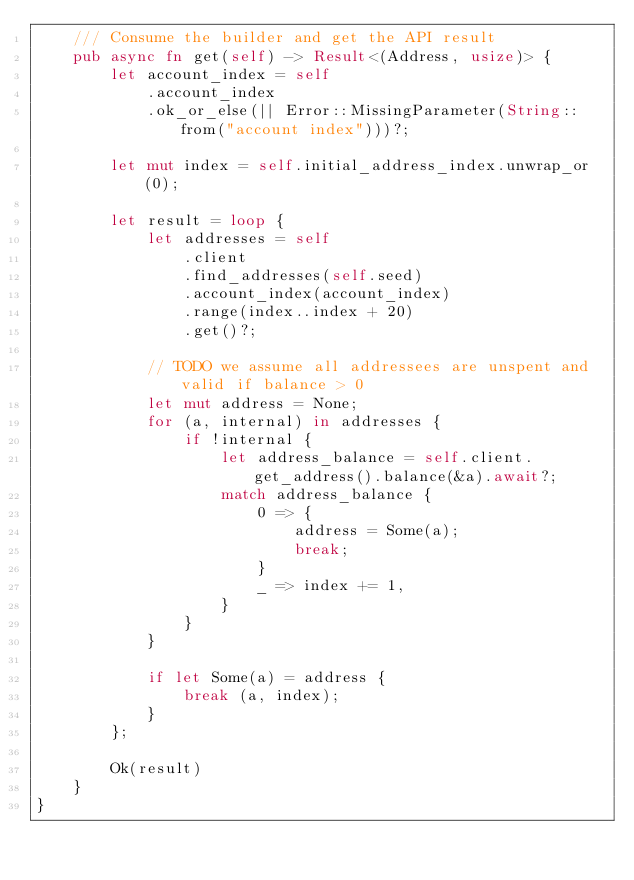Convert code to text. <code><loc_0><loc_0><loc_500><loc_500><_Rust_>    /// Consume the builder and get the API result
    pub async fn get(self) -> Result<(Address, usize)> {
        let account_index = self
            .account_index
            .ok_or_else(|| Error::MissingParameter(String::from("account index")))?;

        let mut index = self.initial_address_index.unwrap_or(0);

        let result = loop {
            let addresses = self
                .client
                .find_addresses(self.seed)
                .account_index(account_index)
                .range(index..index + 20)
                .get()?;

            // TODO we assume all addressees are unspent and valid if balance > 0
            let mut address = None;
            for (a, internal) in addresses {
                if !internal {
                    let address_balance = self.client.get_address().balance(&a).await?;
                    match address_balance {
                        0 => {
                            address = Some(a);
                            break;
                        }
                        _ => index += 1,
                    }
                }
            }

            if let Some(a) = address {
                break (a, index);
            }
        };

        Ok(result)
    }
}
</code> 